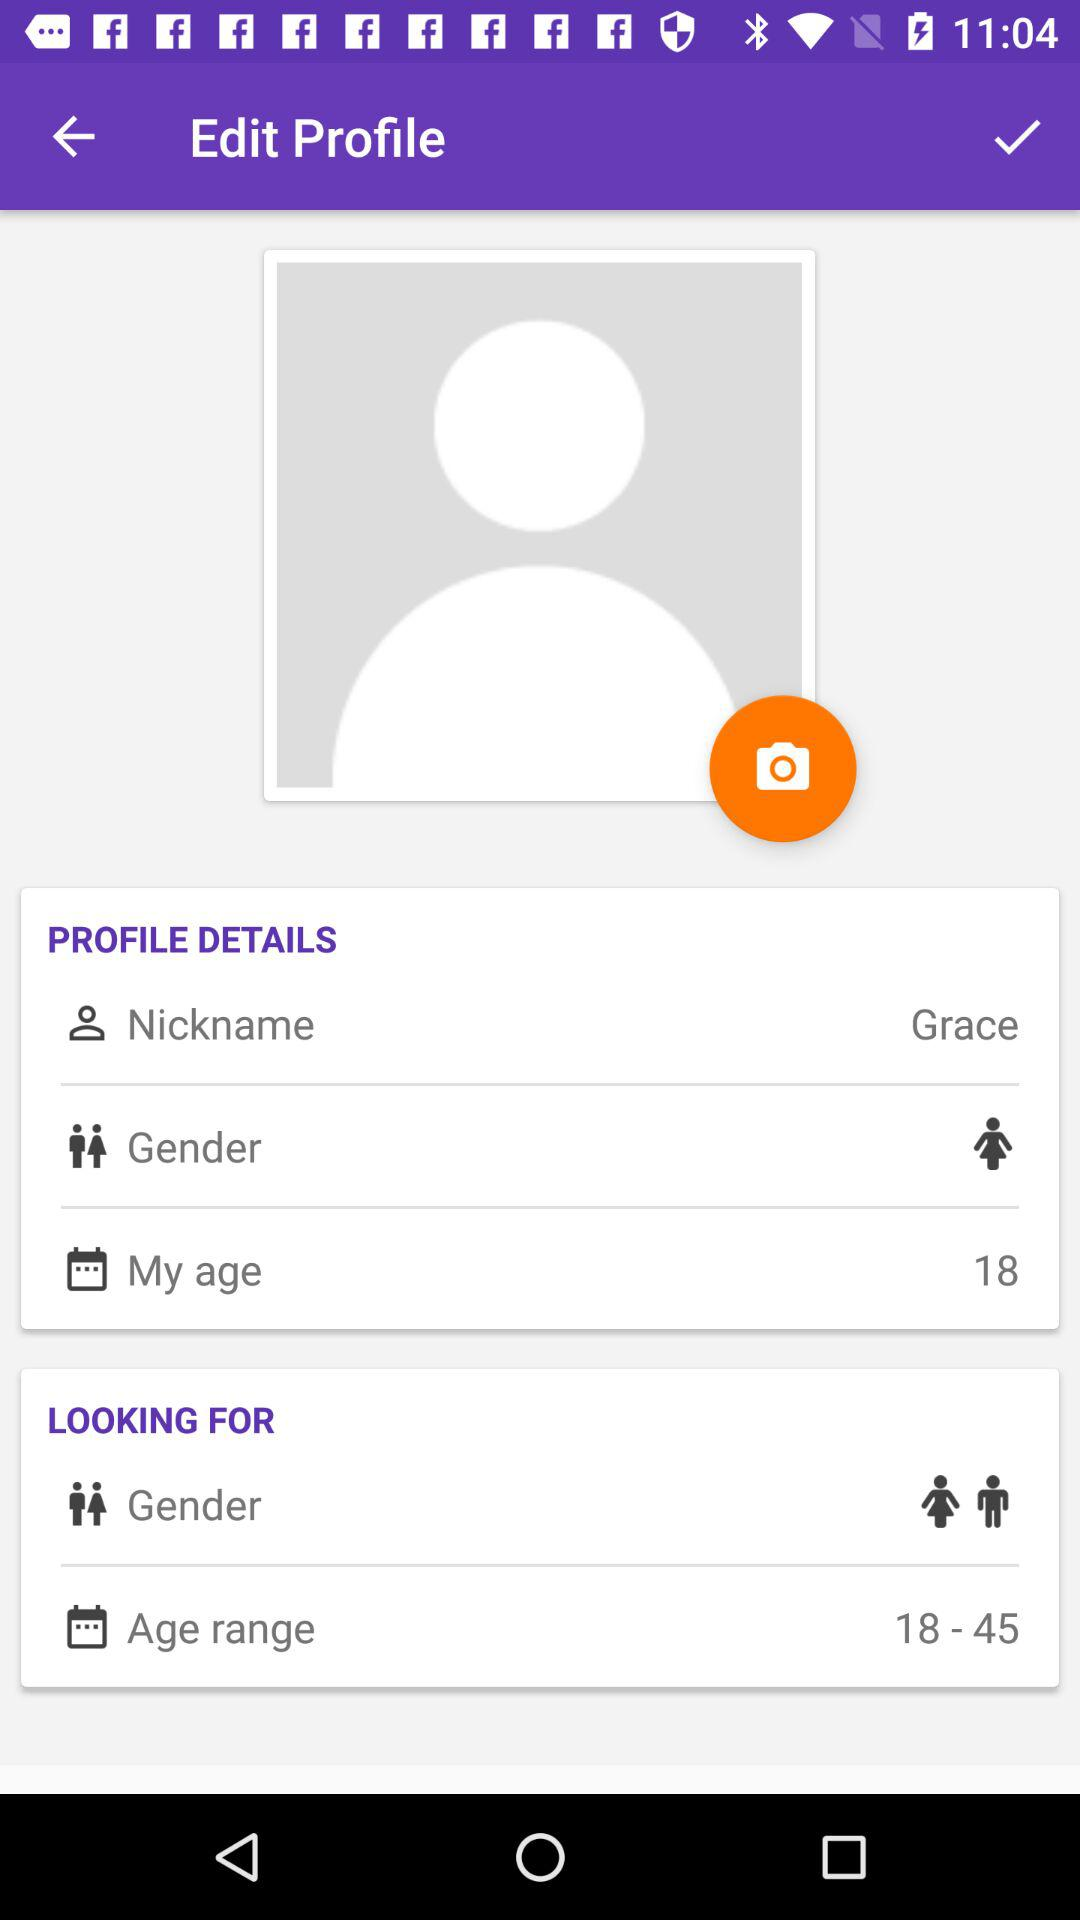What is the given age range? The given age range is from 18 to 45 years. 